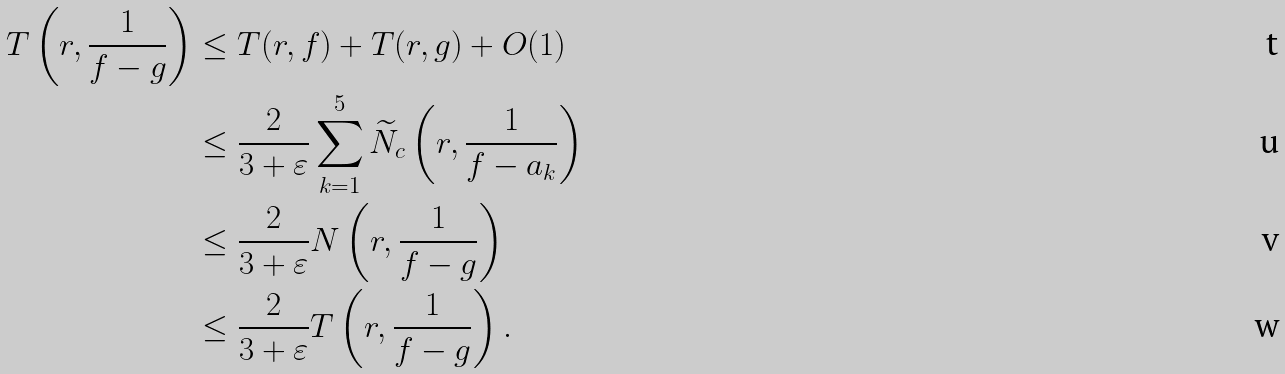Convert formula to latex. <formula><loc_0><loc_0><loc_500><loc_500>T \left ( r , \frac { 1 } { f - g } \right ) & \leq T ( r , f ) + T ( r , g ) + O ( 1 ) \\ & \leq \frac { 2 } { 3 + \varepsilon } \sum _ { k = 1 } ^ { 5 } \widetilde { N } _ { c } \left ( r , \frac { 1 } { f - a _ { k } } \right ) \\ & \leq \frac { 2 } { 3 + \varepsilon } N \left ( r , \frac { 1 } { f - g } \right ) \\ & \leq \frac { 2 } { 3 + \varepsilon } T \left ( r , \frac { 1 } { f - g } \right ) .</formula> 